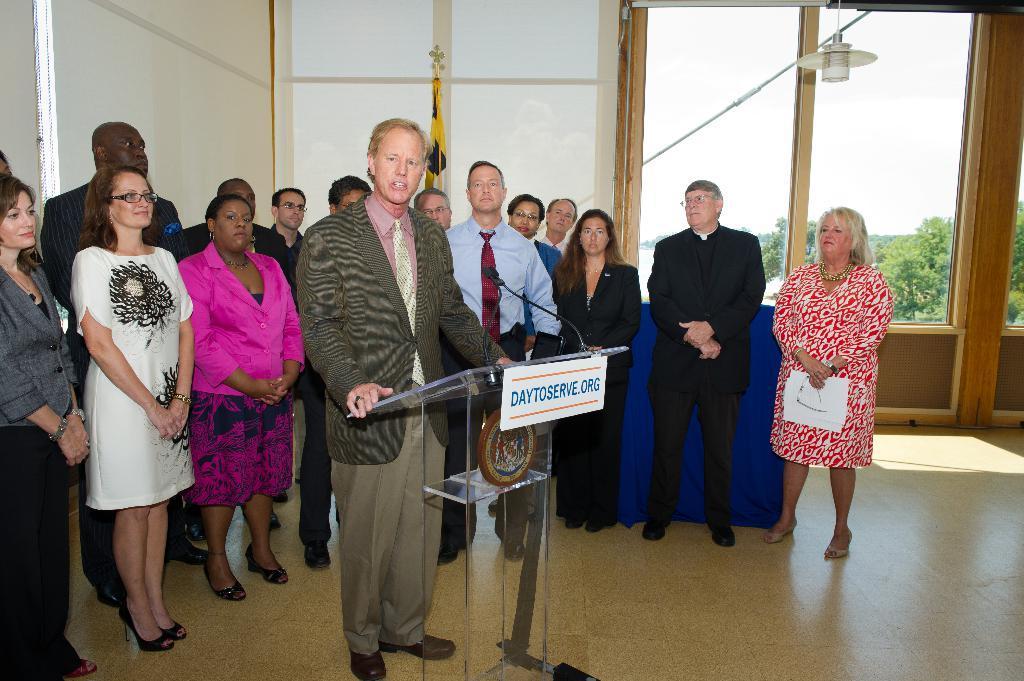In one or two sentences, can you explain what this image depicts? In this image, we can see a group of people are standing. Few are watching and smiling. Here a person is standing near the glass podium and talking in-front of microphones. Here we can see a name board. At the bottom, there is a floor. Background we can see flag, window shades, glass objects and light. Through the glass we can see the outside view. Here there are so many trees and sky. On the right side of the image, we can see a woman is holding some objects. 